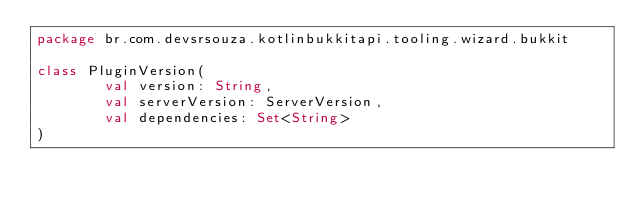<code> <loc_0><loc_0><loc_500><loc_500><_Kotlin_>package br.com.devsrsouza.kotlinbukkitapi.tooling.wizard.bukkit

class PluginVersion(
        val version: String,
        val serverVersion: ServerVersion,
        val dependencies: Set<String>
)</code> 